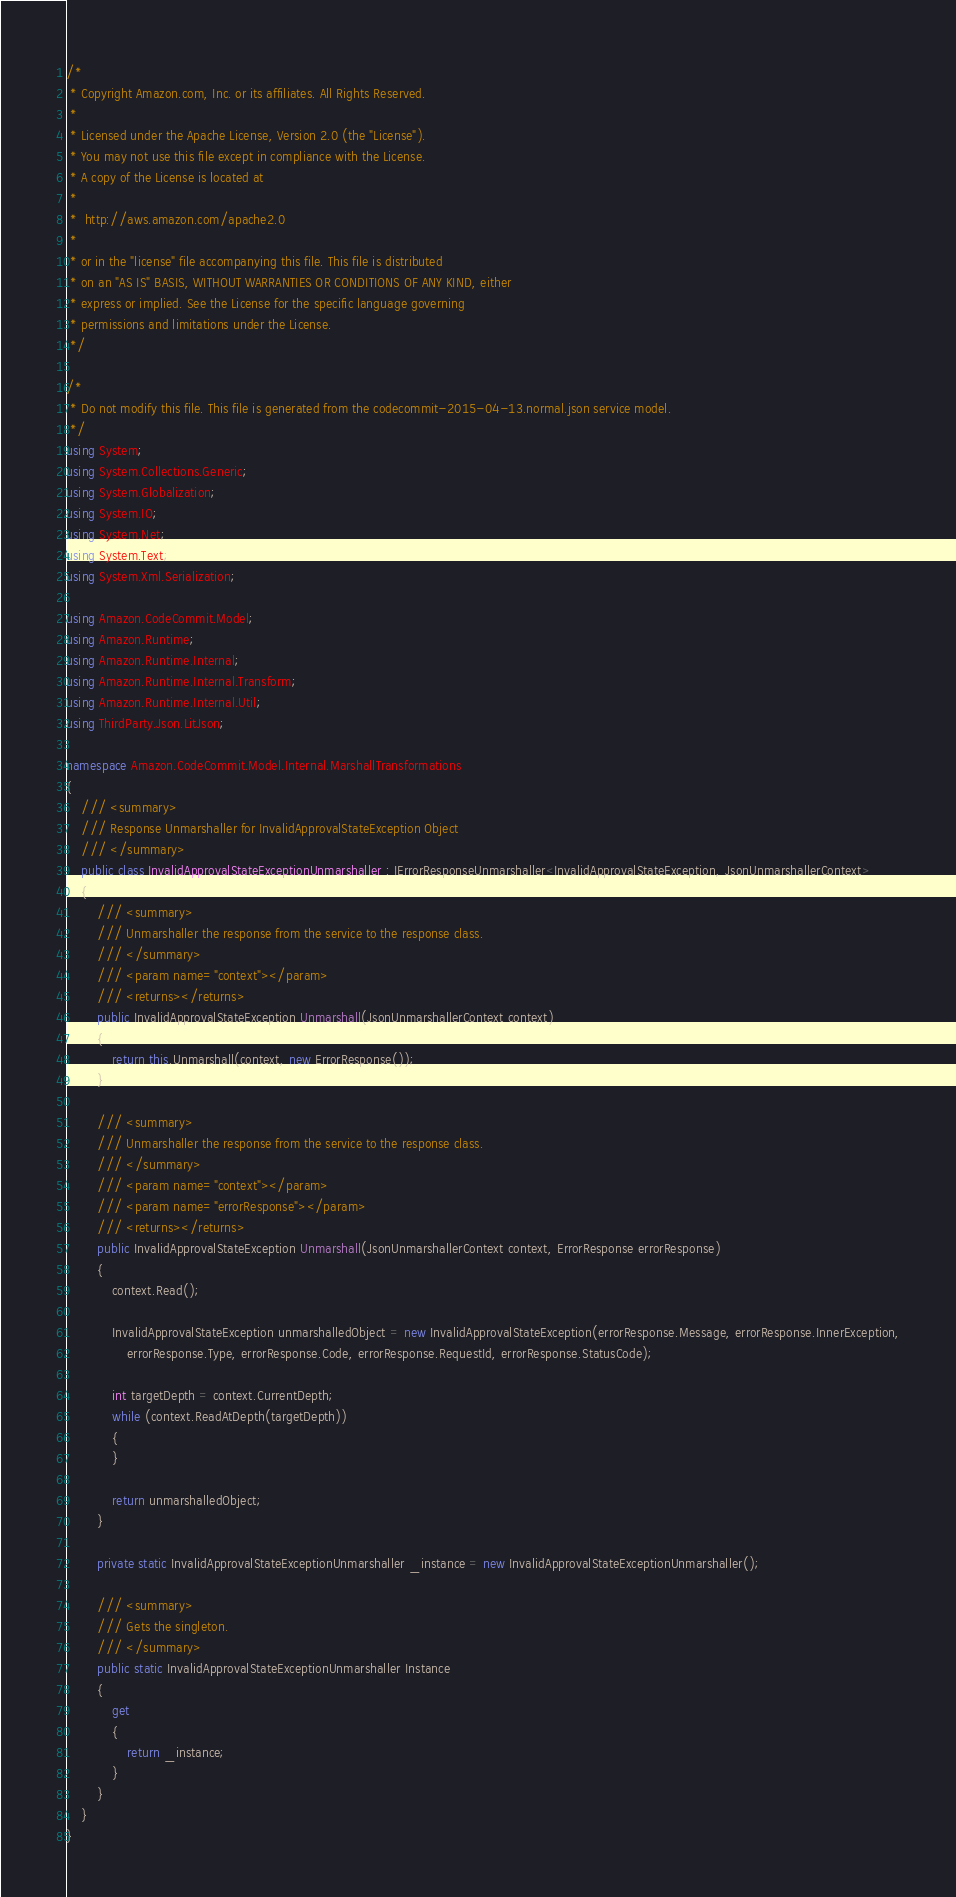<code> <loc_0><loc_0><loc_500><loc_500><_C#_>/*
 * Copyright Amazon.com, Inc. or its affiliates. All Rights Reserved.
 * 
 * Licensed under the Apache License, Version 2.0 (the "License").
 * You may not use this file except in compliance with the License.
 * A copy of the License is located at
 * 
 *  http://aws.amazon.com/apache2.0
 * 
 * or in the "license" file accompanying this file. This file is distributed
 * on an "AS IS" BASIS, WITHOUT WARRANTIES OR CONDITIONS OF ANY KIND, either
 * express or implied. See the License for the specific language governing
 * permissions and limitations under the License.
 */

/*
 * Do not modify this file. This file is generated from the codecommit-2015-04-13.normal.json service model.
 */
using System;
using System.Collections.Generic;
using System.Globalization;
using System.IO;
using System.Net;
using System.Text;
using System.Xml.Serialization;

using Amazon.CodeCommit.Model;
using Amazon.Runtime;
using Amazon.Runtime.Internal;
using Amazon.Runtime.Internal.Transform;
using Amazon.Runtime.Internal.Util;
using ThirdParty.Json.LitJson;

namespace Amazon.CodeCommit.Model.Internal.MarshallTransformations
{
    /// <summary>
    /// Response Unmarshaller for InvalidApprovalStateException Object
    /// </summary>  
    public class InvalidApprovalStateExceptionUnmarshaller : IErrorResponseUnmarshaller<InvalidApprovalStateException, JsonUnmarshallerContext>
    {
        /// <summary>
        /// Unmarshaller the response from the service to the response class.
        /// </summary>  
        /// <param name="context"></param>
        /// <returns></returns>
        public InvalidApprovalStateException Unmarshall(JsonUnmarshallerContext context)
        {
            return this.Unmarshall(context, new ErrorResponse());
        }

        /// <summary>
        /// Unmarshaller the response from the service to the response class.
        /// </summary>  
        /// <param name="context"></param>
        /// <param name="errorResponse"></param>
        /// <returns></returns>
        public InvalidApprovalStateException Unmarshall(JsonUnmarshallerContext context, ErrorResponse errorResponse)
        {
            context.Read();

            InvalidApprovalStateException unmarshalledObject = new InvalidApprovalStateException(errorResponse.Message, errorResponse.InnerException,
                errorResponse.Type, errorResponse.Code, errorResponse.RequestId, errorResponse.StatusCode);
        
            int targetDepth = context.CurrentDepth;
            while (context.ReadAtDepth(targetDepth))
            {
            }
          
            return unmarshalledObject;
        }

        private static InvalidApprovalStateExceptionUnmarshaller _instance = new InvalidApprovalStateExceptionUnmarshaller();        

        /// <summary>
        /// Gets the singleton.
        /// </summary>  
        public static InvalidApprovalStateExceptionUnmarshaller Instance
        {
            get
            {
                return _instance;
            }
        }
    }
}</code> 